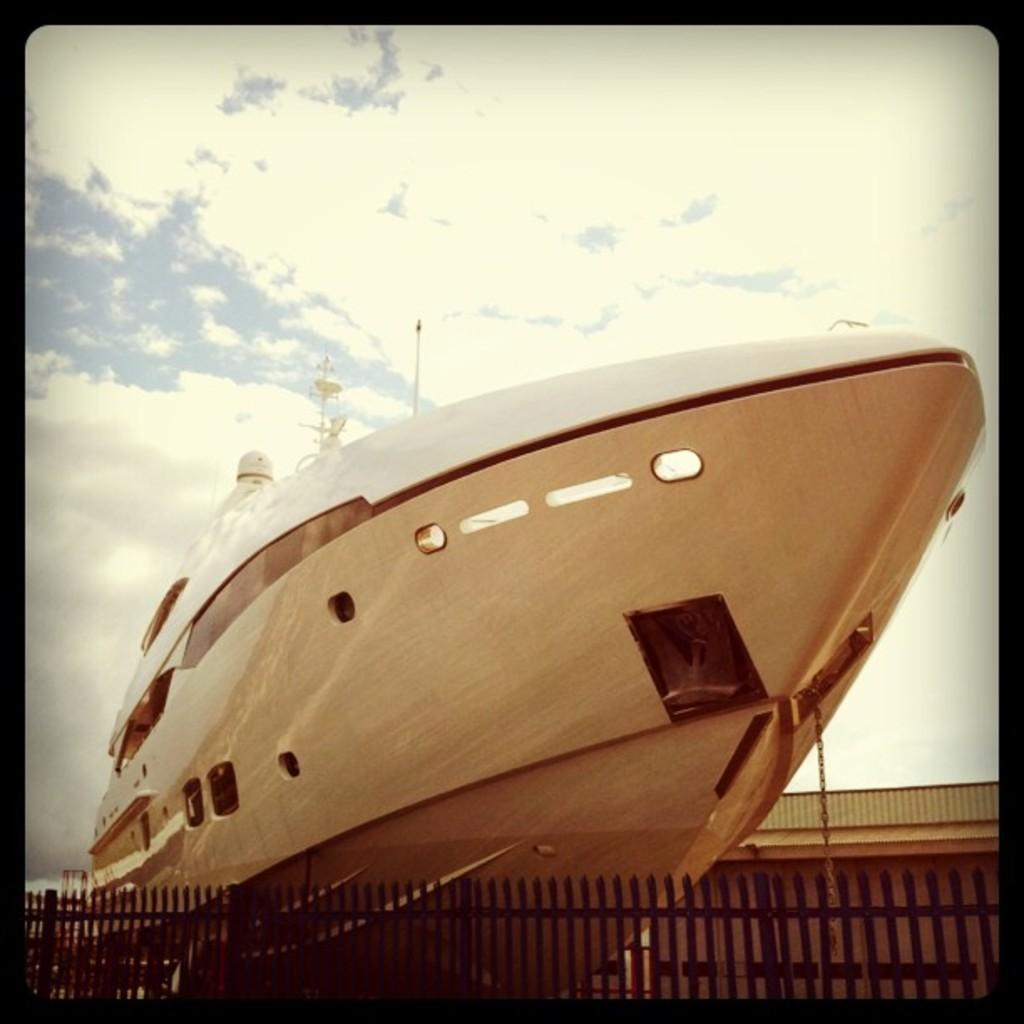What type of vehicle is in the image? There is a motor boat in the image. What type of material is used for the fencing in the image? There is wooden fencing in the image. What can be seen in the sky in the image? Clouds are visible in the sky in the image. How many pieces of art are displayed on the motor boat in the image? There is no art displayed on the motor boat in the image. What type of cattle can be seen grazing near the wooden fencing in the image? There is no cattle present in the image. 